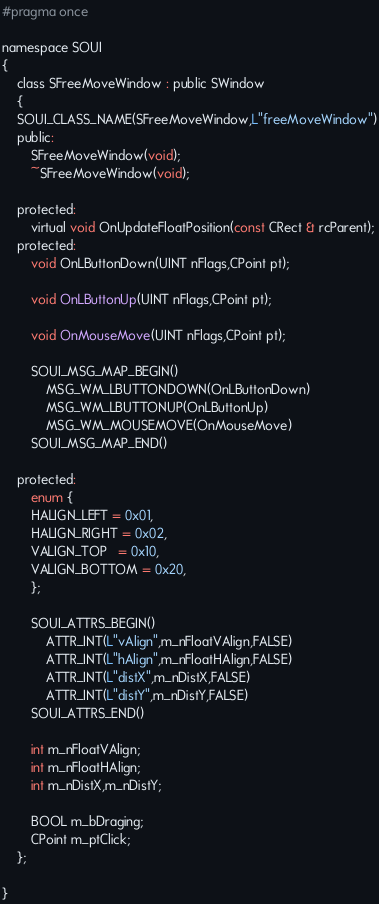Convert code to text. <code><loc_0><loc_0><loc_500><loc_500><_C_>#pragma once

namespace SOUI
{
    class SFreeMoveWindow : public SWindow
    {
    SOUI_CLASS_NAME(SFreeMoveWindow,L"freeMoveWindow")
    public:
        SFreeMoveWindow(void);
        ~SFreeMoveWindow(void);
        
    protected:
        virtual void OnUpdateFloatPosition(const CRect & rcParent);
    protected:
        void OnLButtonDown(UINT nFlags,CPoint pt);

        void OnLButtonUp(UINT nFlags,CPoint pt);

        void OnMouseMove(UINT nFlags,CPoint pt);

        SOUI_MSG_MAP_BEGIN()
            MSG_WM_LBUTTONDOWN(OnLButtonDown)
            MSG_WM_LBUTTONUP(OnLButtonUp)
            MSG_WM_MOUSEMOVE(OnMouseMove)
        SOUI_MSG_MAP_END()
        
    protected:
        enum {
        HALIGN_LEFT = 0x01,
        HALIGN_RIGHT = 0x02,
        VALIGN_TOP   = 0x10,
        VALIGN_BOTTOM = 0x20,
        };
        
        SOUI_ATTRS_BEGIN()
            ATTR_INT(L"vAlign",m_nFloatVAlign,FALSE)
            ATTR_INT(L"hAlign",m_nFloatHAlign,FALSE)
            ATTR_INT(L"distX",m_nDistX,FALSE)
            ATTR_INT(L"distY",m_nDistY,FALSE)
        SOUI_ATTRS_END()
        
        int m_nFloatVAlign;
        int m_nFloatHAlign;
        int m_nDistX,m_nDistY;
        
        BOOL m_bDraging;
        CPoint m_ptClick;
    };

}
</code> 